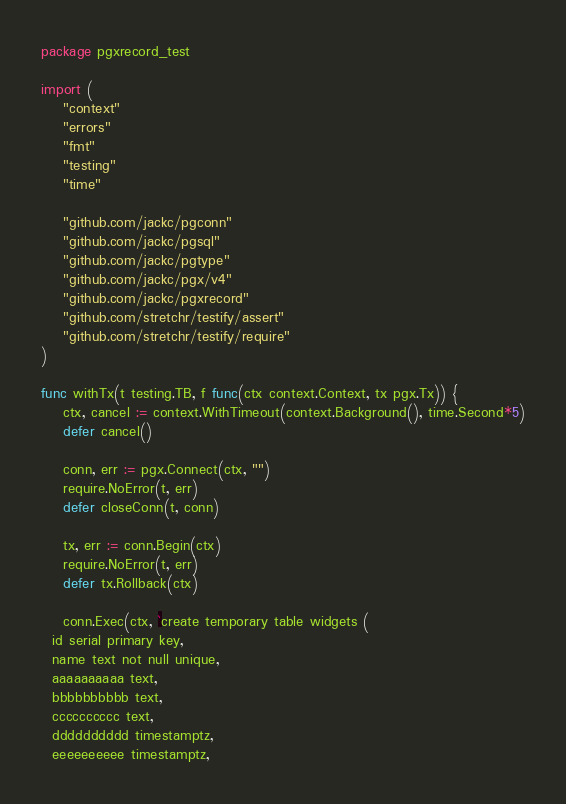<code> <loc_0><loc_0><loc_500><loc_500><_Go_>package pgxrecord_test

import (
	"context"
	"errors"
	"fmt"
	"testing"
	"time"

	"github.com/jackc/pgconn"
	"github.com/jackc/pgsql"
	"github.com/jackc/pgtype"
	"github.com/jackc/pgx/v4"
	"github.com/jackc/pgxrecord"
	"github.com/stretchr/testify/assert"
	"github.com/stretchr/testify/require"
)

func withTx(t testing.TB, f func(ctx context.Context, tx pgx.Tx)) {
	ctx, cancel := context.WithTimeout(context.Background(), time.Second*5)
	defer cancel()

	conn, err := pgx.Connect(ctx, "")
	require.NoError(t, err)
	defer closeConn(t, conn)

	tx, err := conn.Begin(ctx)
	require.NoError(t, err)
	defer tx.Rollback(ctx)

	conn.Exec(ctx, `create temporary table widgets (
  id serial primary key,
  name text not null unique,
  aaaaaaaaaa text,
  bbbbbbbbbb text,
  cccccccccc text,
  dddddddddd timestamptz,
  eeeeeeeeee timestamptz,</code> 